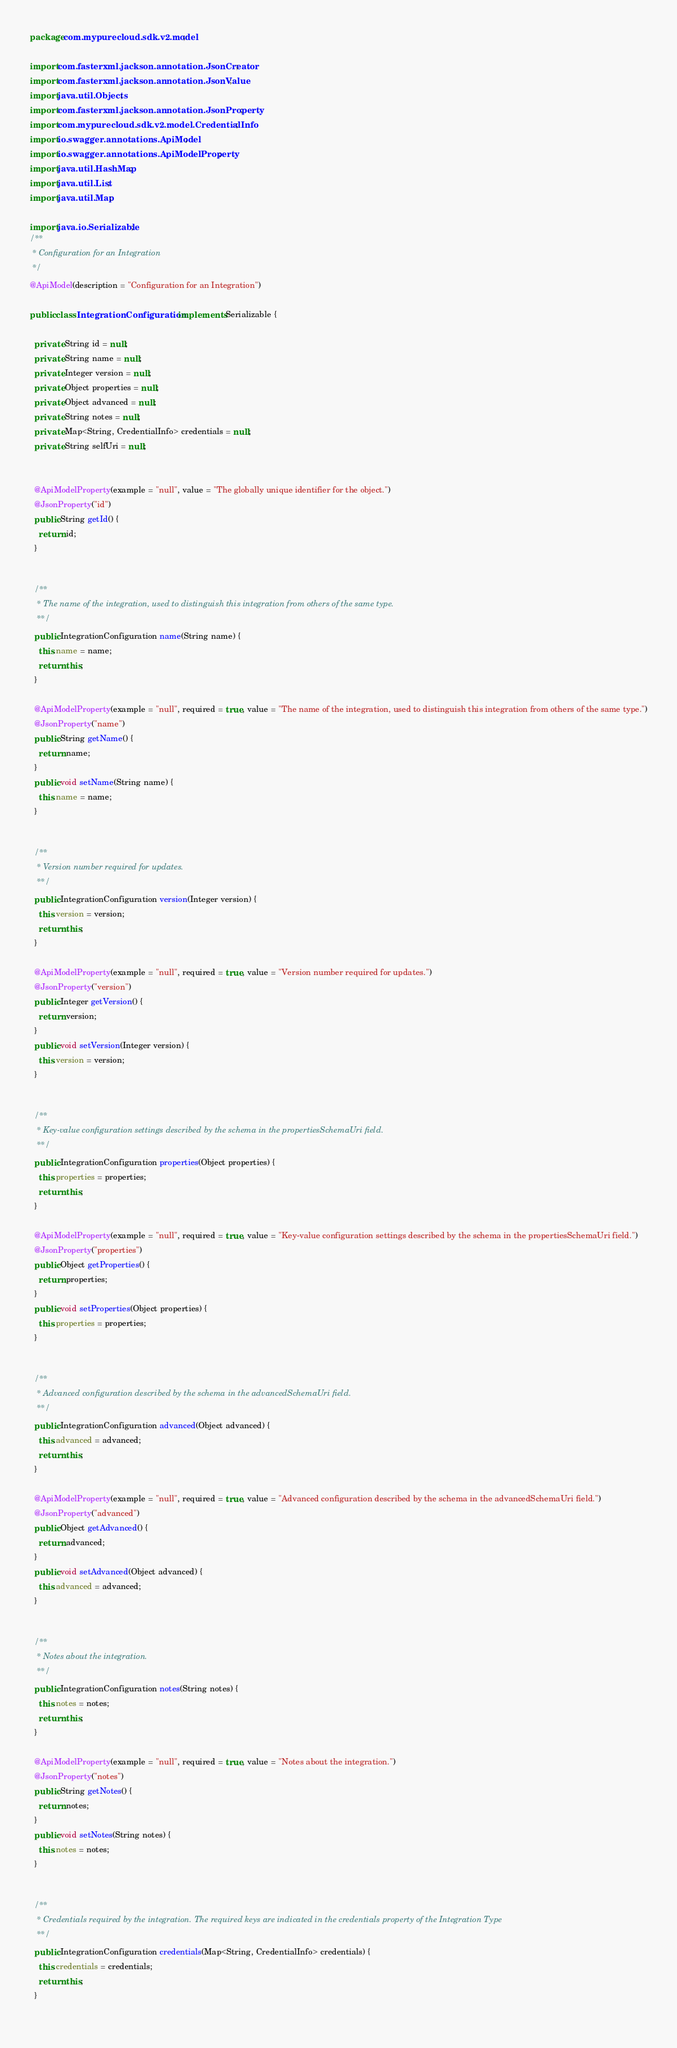<code> <loc_0><loc_0><loc_500><loc_500><_Java_>package com.mypurecloud.sdk.v2.model;

import com.fasterxml.jackson.annotation.JsonCreator;
import com.fasterxml.jackson.annotation.JsonValue;
import java.util.Objects;
import com.fasterxml.jackson.annotation.JsonProperty;
import com.mypurecloud.sdk.v2.model.CredentialInfo;
import io.swagger.annotations.ApiModel;
import io.swagger.annotations.ApiModelProperty;
import java.util.HashMap;
import java.util.List;
import java.util.Map;

import java.io.Serializable;
/**
 * Configuration for an Integration
 */
@ApiModel(description = "Configuration for an Integration")

public class IntegrationConfiguration  implements Serializable {
  
  private String id = null;
  private String name = null;
  private Integer version = null;
  private Object properties = null;
  private Object advanced = null;
  private String notes = null;
  private Map<String, CredentialInfo> credentials = null;
  private String selfUri = null;

  
  @ApiModelProperty(example = "null", value = "The globally unique identifier for the object.")
  @JsonProperty("id")
  public String getId() {
    return id;
  }

  
  /**
   * The name of the integration, used to distinguish this integration from others of the same type.
   **/
  public IntegrationConfiguration name(String name) {
    this.name = name;
    return this;
  }
  
  @ApiModelProperty(example = "null", required = true, value = "The name of the integration, used to distinguish this integration from others of the same type.")
  @JsonProperty("name")
  public String getName() {
    return name;
  }
  public void setName(String name) {
    this.name = name;
  }

  
  /**
   * Version number required for updates.
   **/
  public IntegrationConfiguration version(Integer version) {
    this.version = version;
    return this;
  }
  
  @ApiModelProperty(example = "null", required = true, value = "Version number required for updates.")
  @JsonProperty("version")
  public Integer getVersion() {
    return version;
  }
  public void setVersion(Integer version) {
    this.version = version;
  }

  
  /**
   * Key-value configuration settings described by the schema in the propertiesSchemaUri field.
   **/
  public IntegrationConfiguration properties(Object properties) {
    this.properties = properties;
    return this;
  }
  
  @ApiModelProperty(example = "null", required = true, value = "Key-value configuration settings described by the schema in the propertiesSchemaUri field.")
  @JsonProperty("properties")
  public Object getProperties() {
    return properties;
  }
  public void setProperties(Object properties) {
    this.properties = properties;
  }

  
  /**
   * Advanced configuration described by the schema in the advancedSchemaUri field.
   **/
  public IntegrationConfiguration advanced(Object advanced) {
    this.advanced = advanced;
    return this;
  }
  
  @ApiModelProperty(example = "null", required = true, value = "Advanced configuration described by the schema in the advancedSchemaUri field.")
  @JsonProperty("advanced")
  public Object getAdvanced() {
    return advanced;
  }
  public void setAdvanced(Object advanced) {
    this.advanced = advanced;
  }

  
  /**
   * Notes about the integration.
   **/
  public IntegrationConfiguration notes(String notes) {
    this.notes = notes;
    return this;
  }
  
  @ApiModelProperty(example = "null", required = true, value = "Notes about the integration.")
  @JsonProperty("notes")
  public String getNotes() {
    return notes;
  }
  public void setNotes(String notes) {
    this.notes = notes;
  }

  
  /**
   * Credentials required by the integration. The required keys are indicated in the credentials property of the Integration Type
   **/
  public IntegrationConfiguration credentials(Map<String, CredentialInfo> credentials) {
    this.credentials = credentials;
    return this;
  }
  </code> 